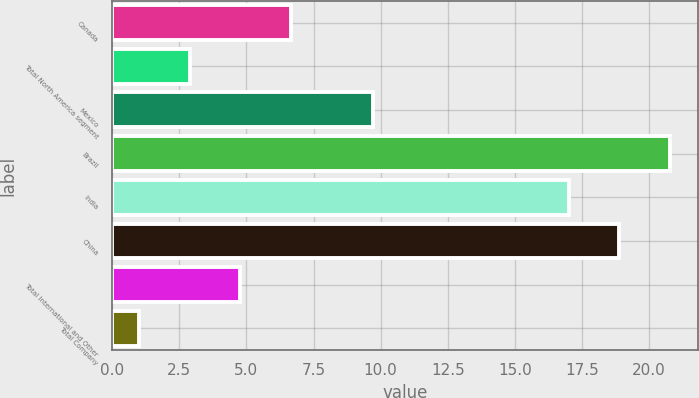<chart> <loc_0><loc_0><loc_500><loc_500><bar_chart><fcel>Canada<fcel>Total North America segment<fcel>Mexico<fcel>Brazil<fcel>India<fcel>China<fcel>Total International and Other<fcel>Total Company<nl><fcel>6.67<fcel>2.89<fcel>9.7<fcel>20.78<fcel>17<fcel>18.89<fcel>4.78<fcel>1<nl></chart> 